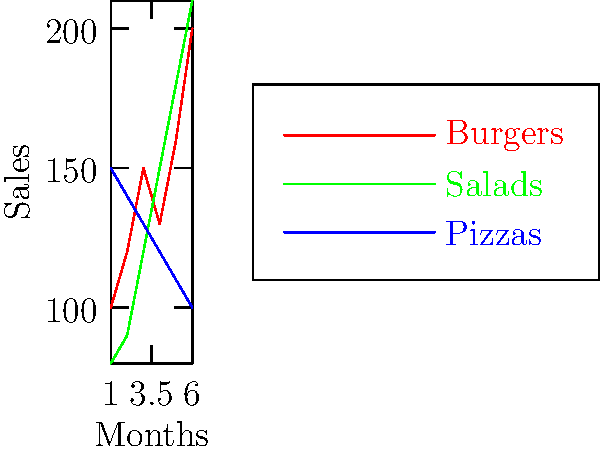As a restaurateur analyzing your menu item sales over the past six months, which item shows the most consistent upward trend, and how might this information influence your future menu planning and inventory management? To answer this question, we need to analyze the sales trends for each menu item:

1. Burgers (red line):
   - Shows an overall upward trend but with some fluctuations
   - Starts at 100 units and ends at 200 units

2. Salads (green line):
   - Displays a consistent upward trend
   - Starts at 80 units and steadily increases to 210 units

3. Pizzas (blue line):
   - Shows a consistent downward trend
   - Starts at 150 units and decreases to 100 units

Salads show the most consistent upward trend, with a steady increase in sales each month.

This information can influence future menu planning and inventory management in several ways:

1. Increase focus on salads:
   - Expand salad offerings
   - Ensure adequate ingredients are stocked
   - Consider featuring salads in promotions

2. Investigate pizza sales decline:
   - Assess quality and customer feedback
   - Consider menu updates or marketing strategies

3. Maintain burger offerings:
   - Despite fluctuations, burgers show overall growth
   - Consider ways to stabilize sales

4. Adjust inventory:
   - Increase stock of salad ingredients
   - Potentially reduce pizza ingredient orders
   - Maintain flexible burger ingredient inventory

5. Staff training:
   - Focus on salad preparation and presentation
   - Cross-train staff to handle increased salad orders

By recognizing the consistent growth in salad sales, you can capitalize on this trend while addressing the performance of other menu items to optimize your restaurant's offerings and operations.
Answer: Salads; increase salad focus, adjust inventory, and address declining pizza sales. 